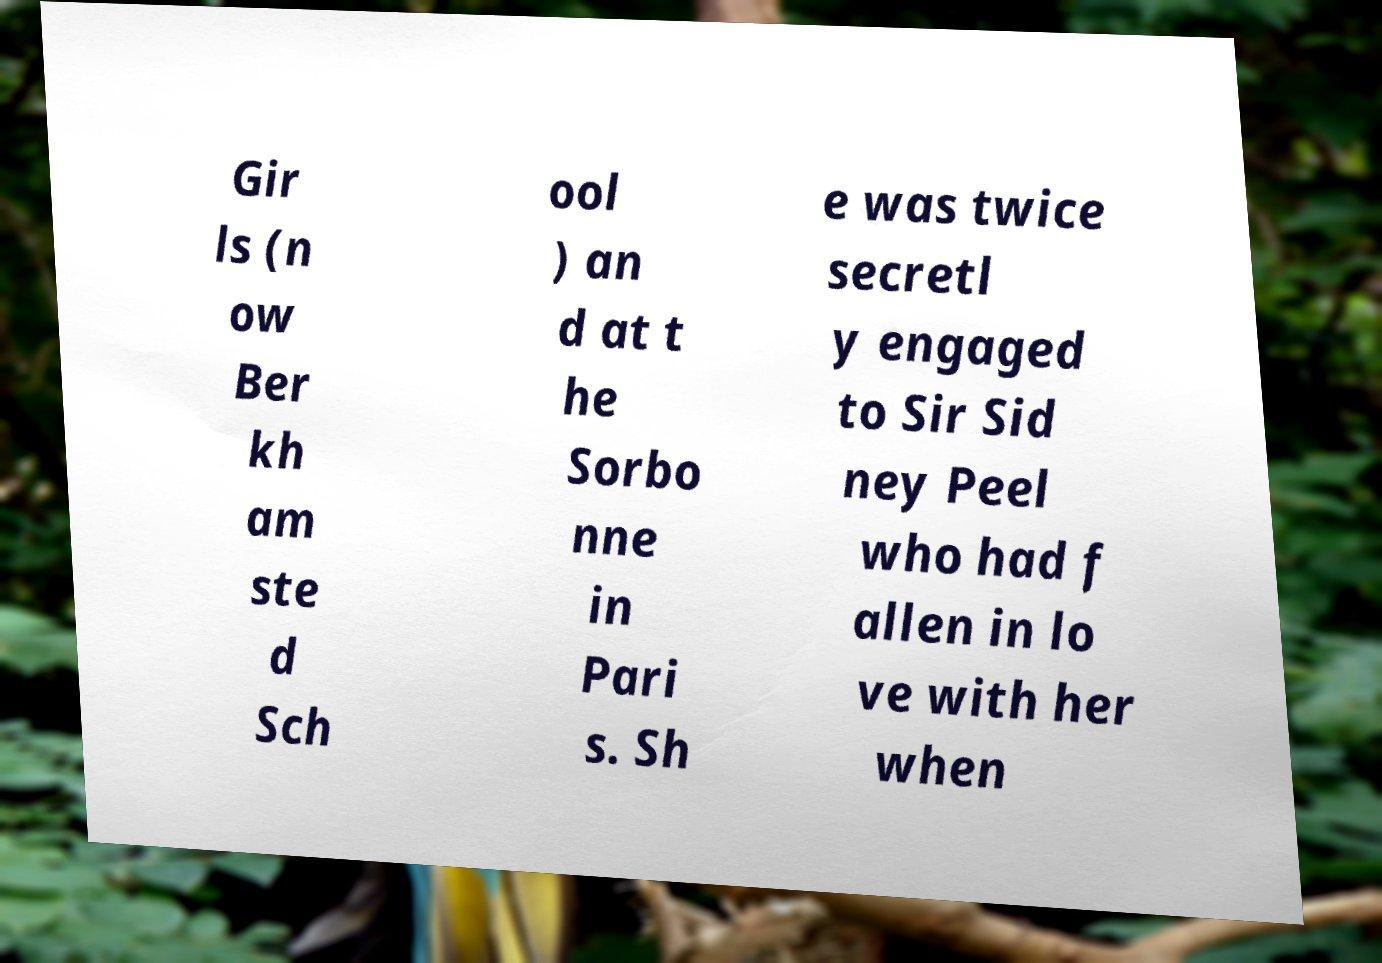Please read and relay the text visible in this image. What does it say? Gir ls (n ow Ber kh am ste d Sch ool ) an d at t he Sorbo nne in Pari s. Sh e was twice secretl y engaged to Sir Sid ney Peel who had f allen in lo ve with her when 